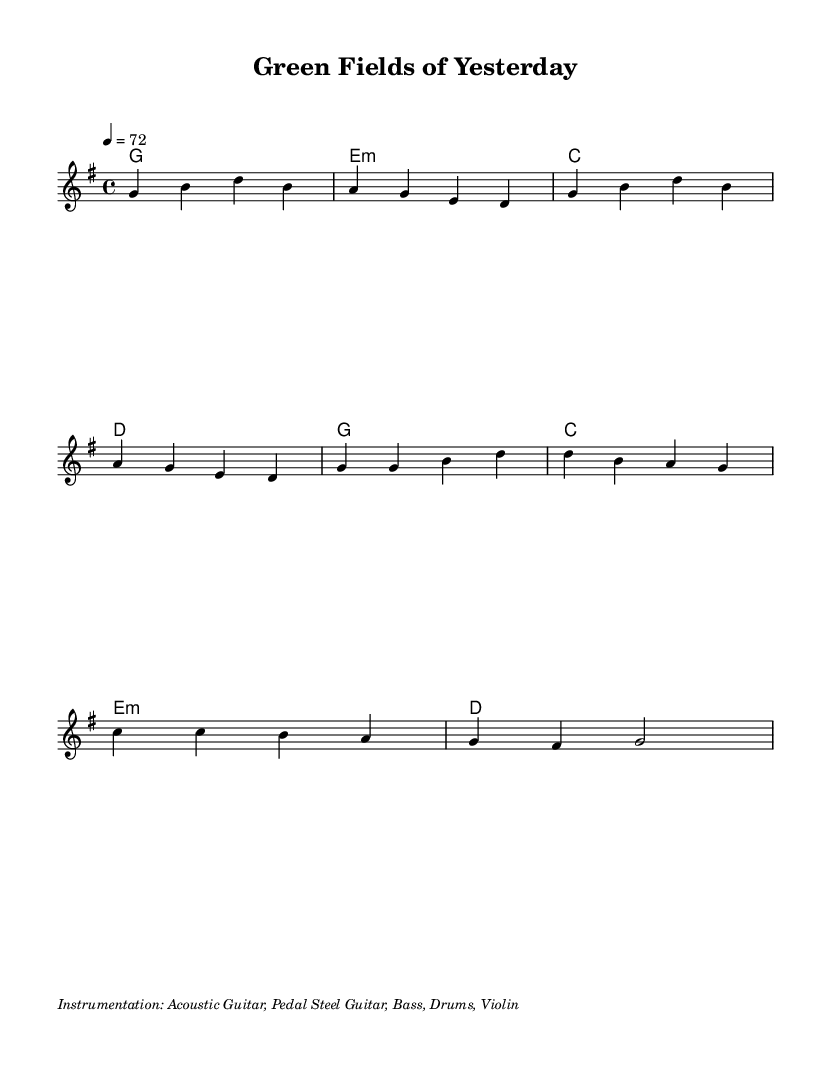What is the key signature of this music? The key signature indicated in the sheet music is G major, which has one sharp (F#). This can be confirmed by looking at the key signature at the beginning of the staff where G major is notated.
Answer: G major What is the time signature of the piece? The time signature is 4/4, which is also shown at the beginning of the music. This means there are four beats in each measure, and the quarter note gets one beat.
Answer: 4/4 What is the tempo marking for this piece? The tempo marking is 4 = 72, indicating that there are 72 beats per minute. The number 4 represents a quarter note, which is the note value counted for the tempo.
Answer: 72 How many measures are in the verse section? The verse section consists of four measures, as indicated in the music notation where the verse melody corresponds to four sets of notes before moving to the chorus.
Answer: 4 What instruments are featured in this arrangement? The instruments listed in the markup include Acoustic Guitar, Pedal Steel Guitar, Bass, Drums, and Violin. This can be verified in the instrumentation note at the end of the music.
Answer: Acoustic Guitar, Pedal Steel Guitar, Bass, Drums, Violin What is the lyrical theme of the chorus? The theme of the chorus expresses a longing for the green fields of the past, as indicated by the lyrics “Oh, those green fields of yesterday, How I long for them today.” This reflects a nostalgic sentiment.
Answer: Nostalgic longing Which musical section comes after the verse? After the verse, the chorus section follows. This can be identified where the music shifts from the verse melody to a new thematic material that conveys a different lyrical sentiment.
Answer: Chorus 